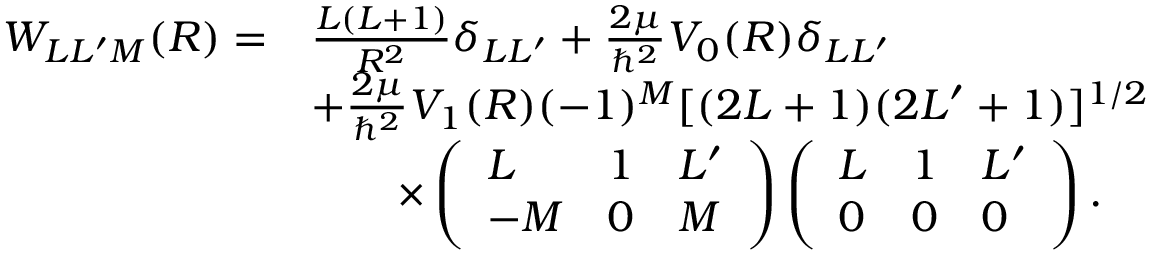<formula> <loc_0><loc_0><loc_500><loc_500>\begin{array} { r l } { W _ { L L ^ { \prime } M } ( R ) = } & { \frac { L ( L + 1 ) } { R ^ { 2 } } \delta _ { L L ^ { \prime } } + \frac { 2 \mu } { \hbar { ^ } { 2 } } V _ { 0 } ( R ) \delta _ { L L ^ { \prime } } } \\ & { + \frac { 2 \mu } { \hbar { ^ } { 2 } } V _ { 1 } ( R ) ( - 1 ) ^ { M } [ ( 2 L + 1 ) ( 2 L ^ { \prime } + 1 ) ] ^ { 1 / 2 } } \\ & { \quad \times \left ( \begin{array} { l l l } { L } & { 1 } & { L ^ { \prime } } \\ { - M } & { 0 } & { M } \end{array} \right ) \left ( \begin{array} { l l l } { L } & { 1 } & { L ^ { \prime } } \\ { 0 } & { 0 } & { 0 } \end{array} \right ) . } \end{array}</formula> 